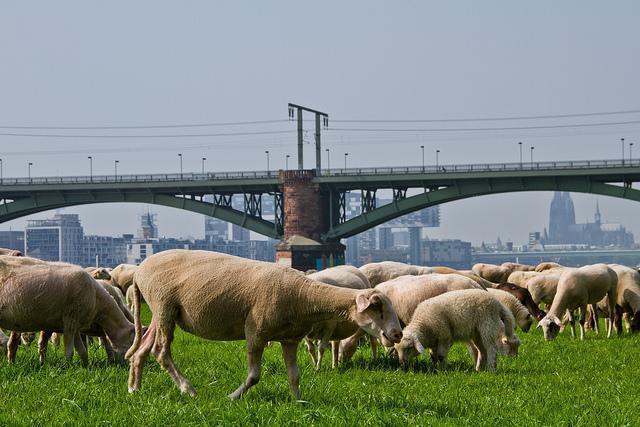What color is the cast iron component in the bridge above the grassy field?
Choose the correct response, then elucidate: 'Answer: answer
Rationale: rationale.'
Options: Red, green, rust, blue. Answer: green.
Rationale: This is obvious in the scene and a common color used on steel bridges. What are the animals near?
Answer the question by selecting the correct answer among the 4 following choices.
Options: Basilica, bridge, cliff, ocean. Bridge. 